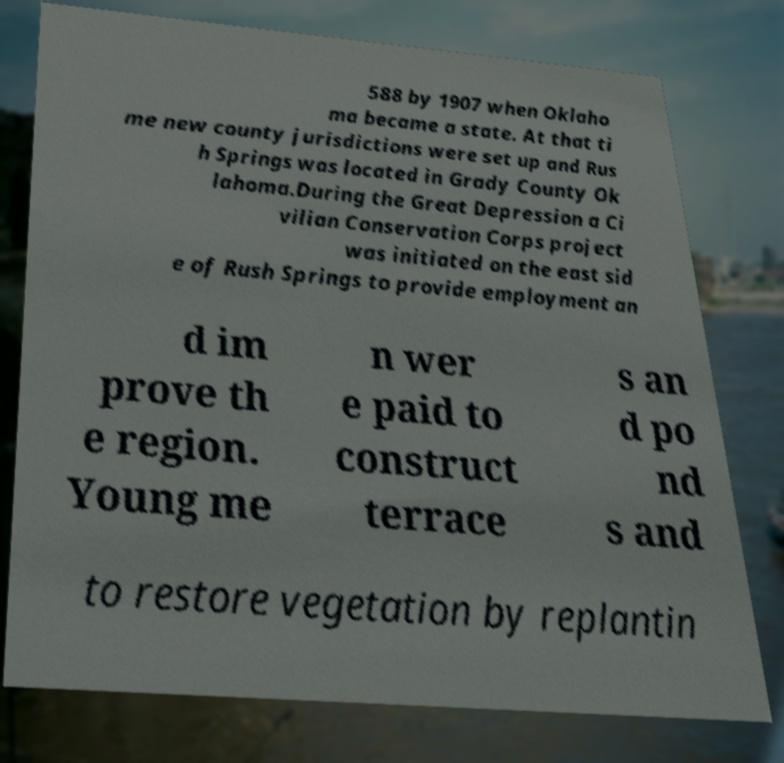Could you extract and type out the text from this image? 588 by 1907 when Oklaho ma became a state. At that ti me new county jurisdictions were set up and Rus h Springs was located in Grady County Ok lahoma.During the Great Depression a Ci vilian Conservation Corps project was initiated on the east sid e of Rush Springs to provide employment an d im prove th e region. Young me n wer e paid to construct terrace s an d po nd s and to restore vegetation by replantin 